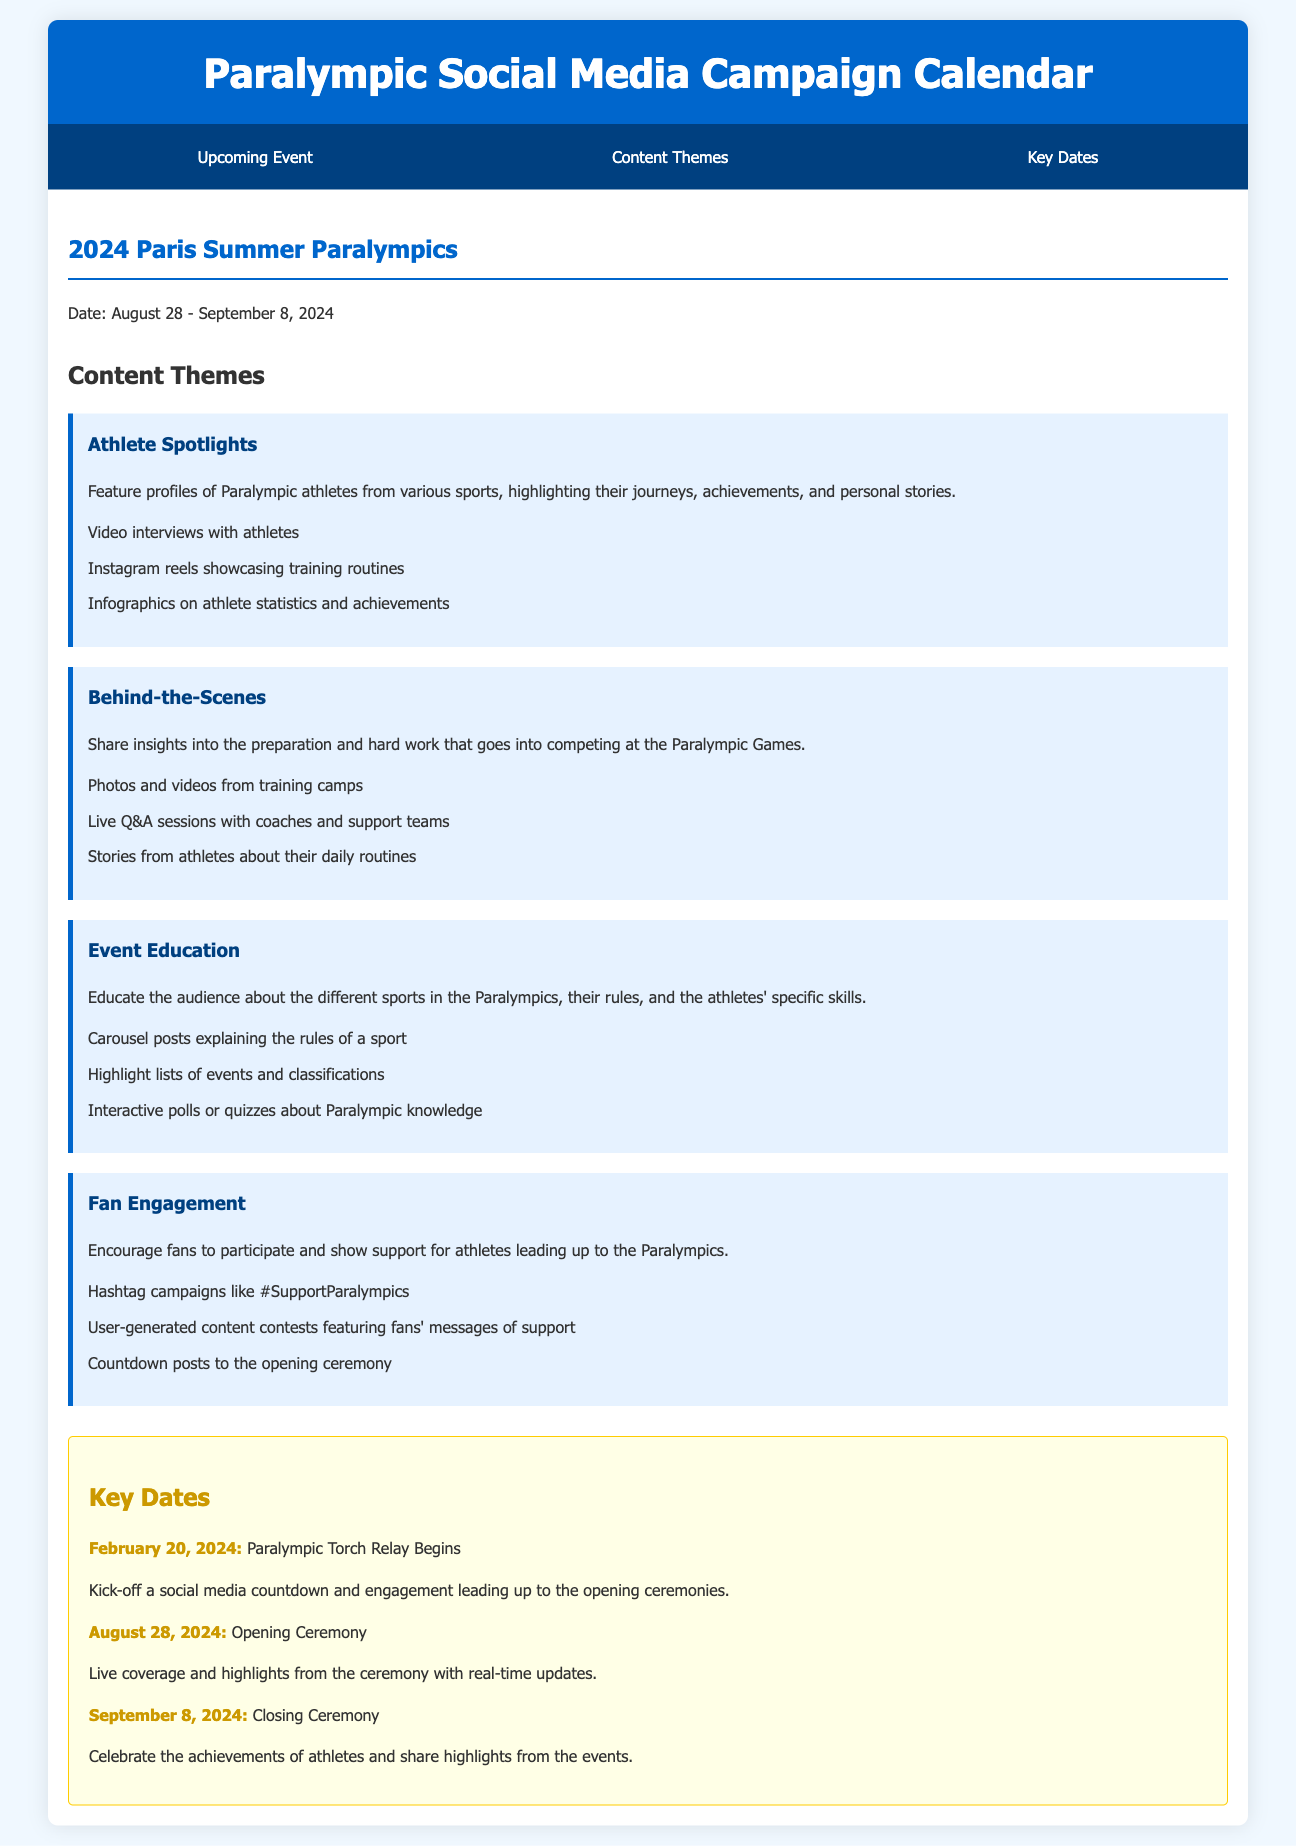What are the dates of the 2024 Paris Summer Paralympics? The document specifies the exact dates for the event, which are from August 28 to September 8, 2024.
Answer: August 28 - September 8, 2024 What is one of the content themes listed? The document includes several themes, as indicated in the section about content themes, like "Athlete Spotlights."
Answer: Athlete Spotlights What begins on February 20, 2024? The document indicates that this date marks the start of the Paralympic Torch Relay.
Answer: Paralympic Torch Relay Begins What should be highlighted during the Opening Ceremony? The document mentions that live coverage and highlights from the ceremony are to be shared with real-time updates.
Answer: Live coverage and highlights Which theme involves user-generated content contests? The document specifies that the "Fan Engagement" theme encourages such contests.
Answer: Fan Engagement How long does the Paralympic Torch Relay last? The document does not specify the duration, but it begins on February 20, 2024, and the Opening Ceremony is on August 28, 2024, suggesting several months.
Answer: Several months What is the goal of the content theme "Event Education"? The document states that this theme aims to educate the audience about the different sports in the Paralympics and their rules.
Answer: Educate the audience What type of posts are suggested for fan engagement? The document includes examples of posts to encourage fan participation, such as hashtag campaigns and countdown posts.
Answer: Hashtag campaigns like #SupportParalympics 